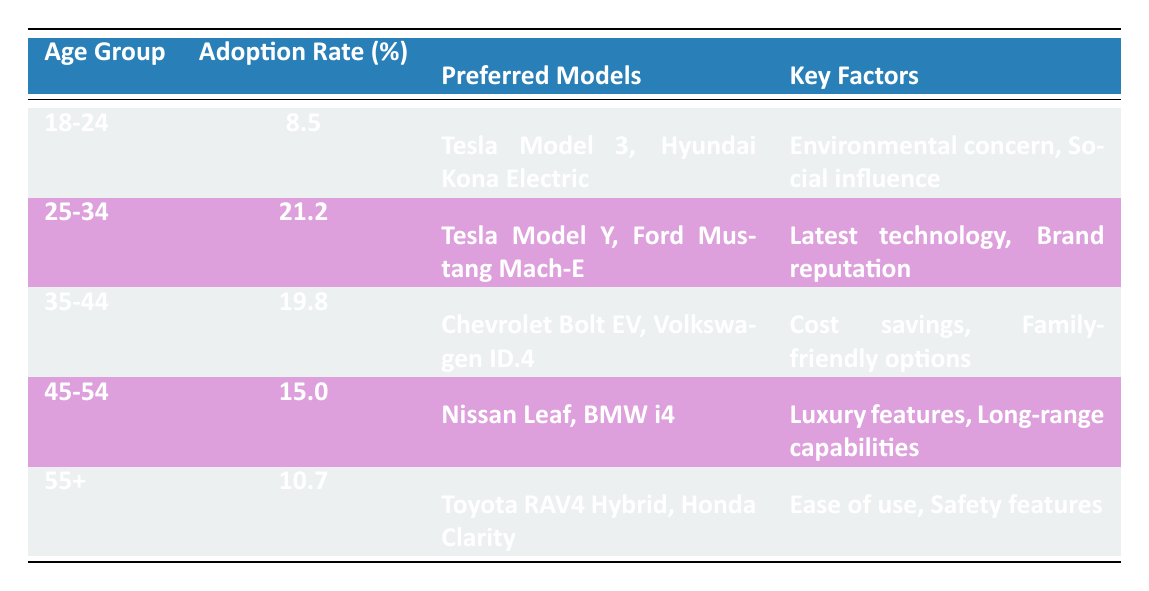What is the adoption rate for the 25-34 age group? The table lists the adoption rate for the 25-34 age group directly, which is 21.2%.
Answer: 21.2% Which age group has the highest adoption rate? By comparing the adoption rates listed in the table, the 25-34 age group has the highest rate at 21.2%.
Answer: 25-34 What are the preferred models for the 35-44 age group? The table specifies the preferred models for the 35-44 age group as Chevrolet Bolt EV and Volkswagen ID.4.
Answer: Chevrolet Bolt EV, Volkswagen ID.4 Is the adoption rate for the 45-54 age group higher than the 55+ age group? By comparing the adoption rates, the 45-54 age group has an adoption rate of 15.0%, while the 55+ group has a rate of 10.7%. Since 15.0% is greater than 10.7%, the statement is true.
Answer: Yes What is the average adoption rate of all age groups combined? To find the average, add the adoption rates: 8.5 + 21.2 + 19.8 + 15.0 + 10.7 = 75.2. There are 5 age groups, so dividing this sum by 5 gives an average of 75.2 / 5 = 15.04.
Answer: 15.04 Which age group has cost savings as a key factor? The table shows that the 35-44 age group lists "Cost savings" among their key factors.
Answer: 35-44 Are luxury features a key factor for the 18-24 age group? The table indicates that the key factors for the 18-24 age group are "Environmental concern" and "Social influence," not "Luxury features." Therefore, the answer is no.
Answer: No How many age groups prefer the Tesla Model? The preferred models listed in the table show that both the 18-24 and 25-34 age groups list Tesla models (Model 3 and Model Y respectively). Thus, two age groups prefer Tesla models.
Answer: 2 